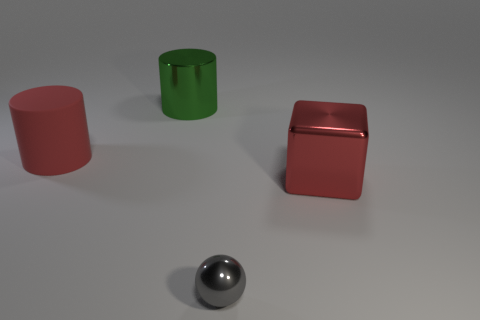Is there any other thing that is the same material as the red cylinder?
Your response must be concise. No. Is there any other thing that has the same size as the gray sphere?
Your answer should be very brief. No. The big red object to the left of the big metal object that is behind the red rubber object is what shape?
Your answer should be very brief. Cylinder. Is the color of the matte cylinder the same as the ball?
Give a very brief answer. No. Is the number of gray objects that are to the left of the small gray object greater than the number of metal things?
Ensure brevity in your answer.  No. How many big red rubber things are on the right side of the thing that is to the right of the tiny gray metallic sphere?
Provide a short and direct response. 0. Is the material of the red object that is on the left side of the shiny cylinder the same as the big red object in front of the large matte thing?
Your answer should be very brief. No. What material is the large thing that is the same color as the big cube?
Offer a terse response. Rubber. How many other big objects are the same shape as the big red shiny thing?
Ensure brevity in your answer.  0. Is the ball made of the same material as the object to the right of the sphere?
Your answer should be compact. Yes. 